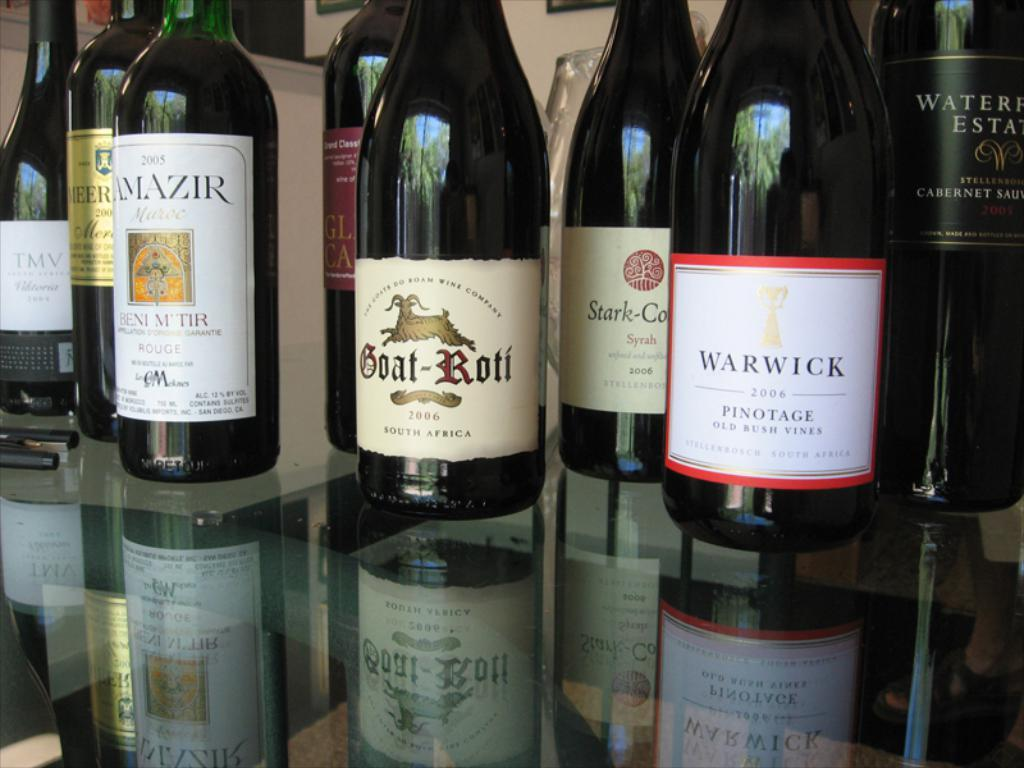<image>
Share a concise interpretation of the image provided. A bottle of Goat Roti sits near a bottle of Warwick wine. 